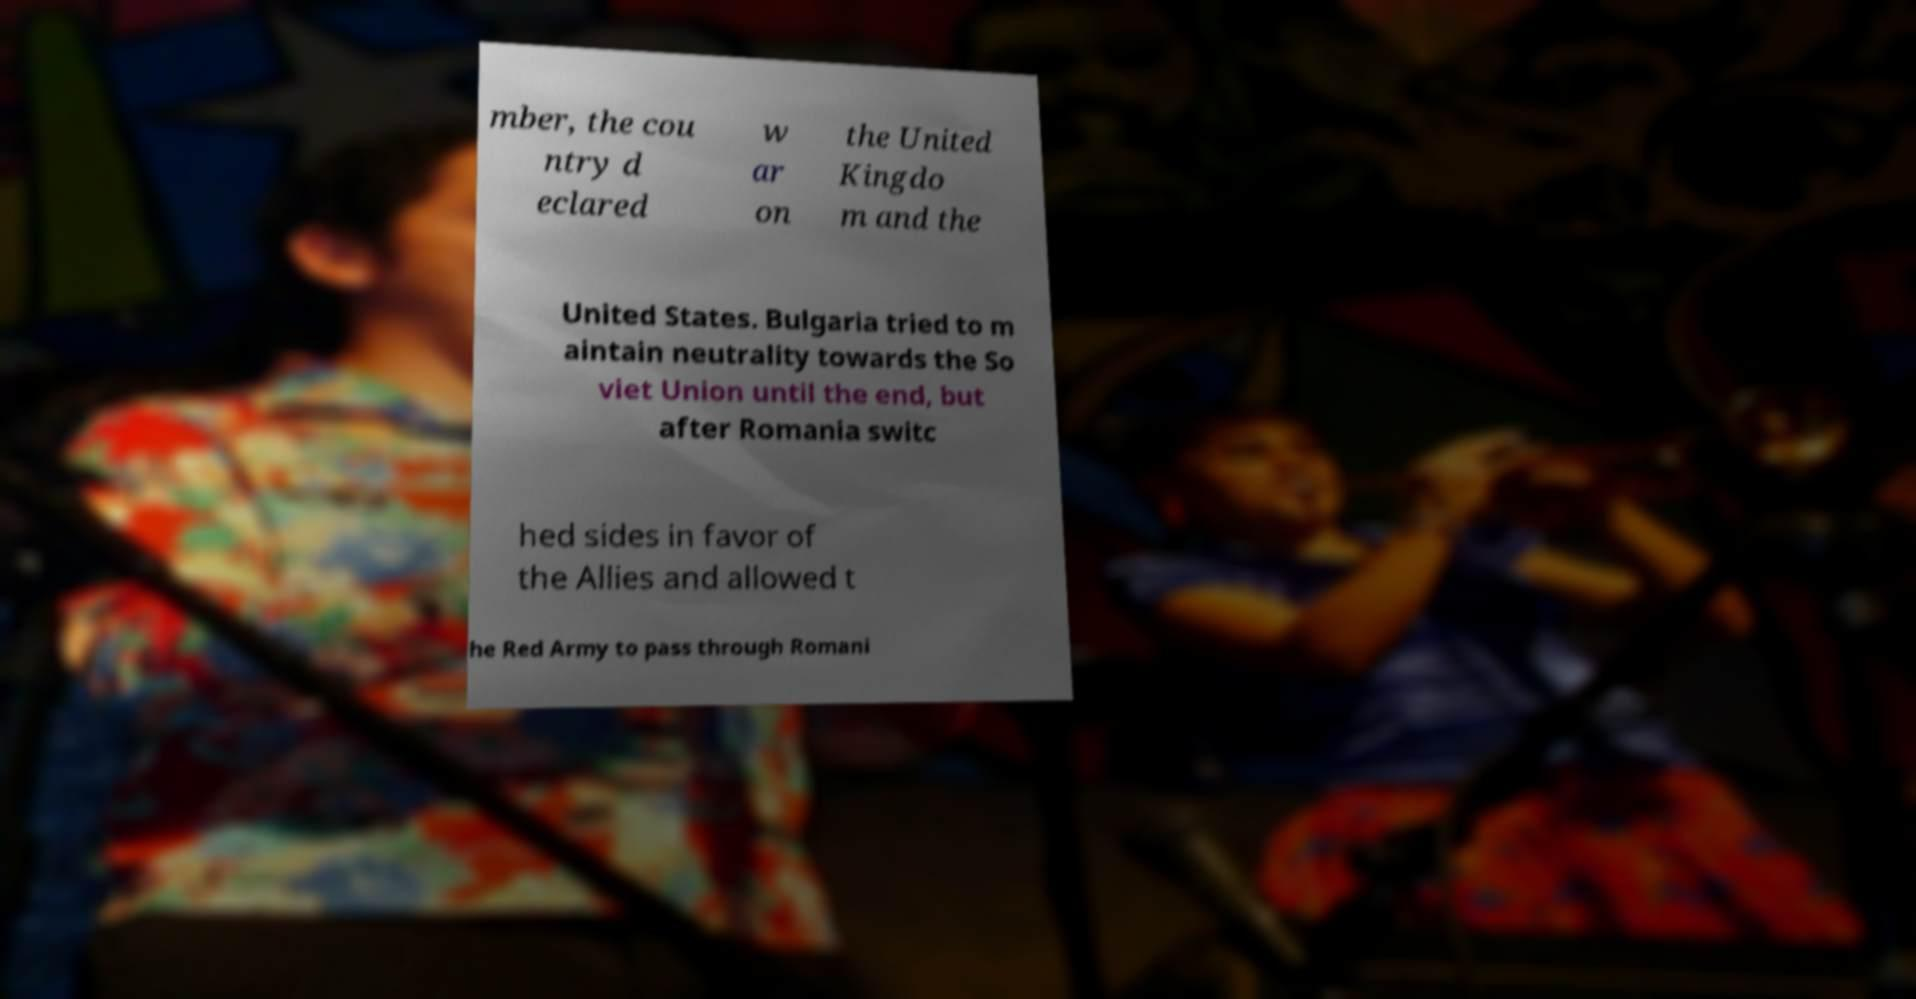For documentation purposes, I need the text within this image transcribed. Could you provide that? mber, the cou ntry d eclared w ar on the United Kingdo m and the United States. Bulgaria tried to m aintain neutrality towards the So viet Union until the end, but after Romania switc hed sides in favor of the Allies and allowed t he Red Army to pass through Romani 